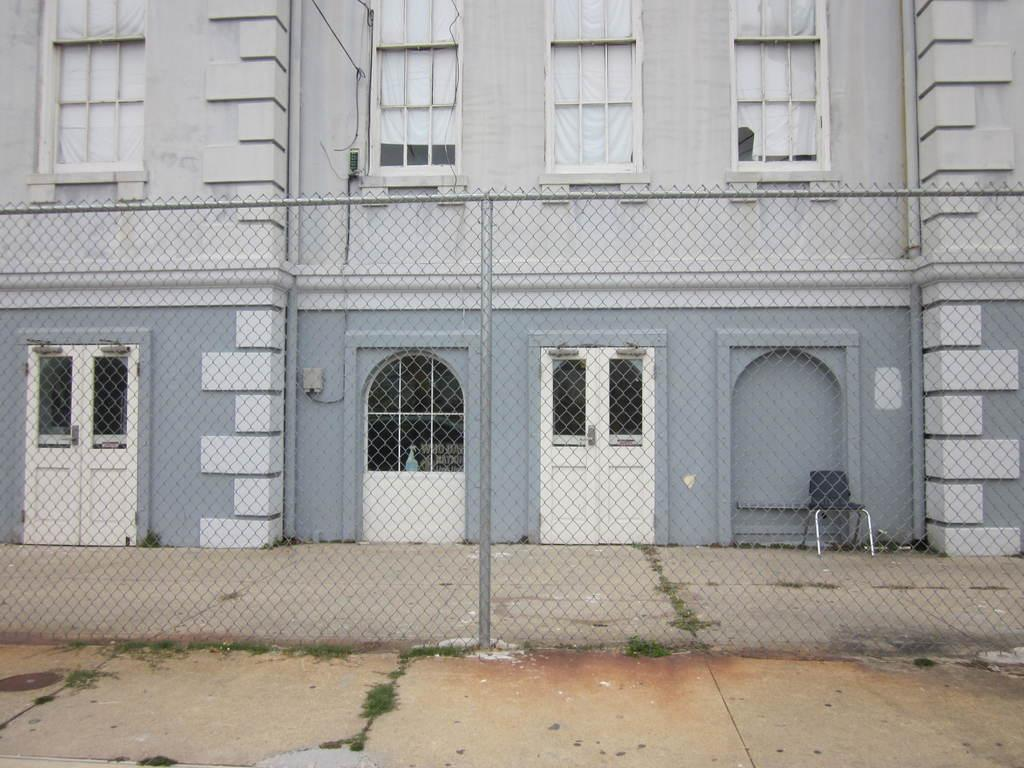What is the main structure in the center of the image? There is a building in the center of the image. What can be seen at the bottom of the image? There is a mesh at the bottom of the image. What type of furniture is on the right side of the image? There is a chair on the right side of the image. How many ducks are swimming in the water near the building in the image? There are no ducks or water present in the image; it features a building, a mesh, and a chair. What type of lettuce is growing in the garden near the chair? There is no garden or lettuce present in the image; it only features a building, a mesh, and a chair. 